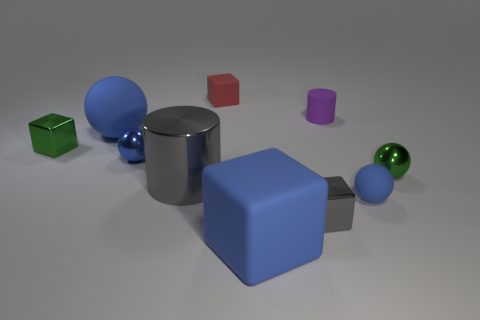Subtract all green cylinders. How many blue balls are left? 3 Subtract 1 spheres. How many spheres are left? 3 Subtract all balls. How many objects are left? 6 Add 5 big blue blocks. How many big blue blocks are left? 6 Add 1 small blue shiny balls. How many small blue shiny balls exist? 2 Subtract 1 purple cylinders. How many objects are left? 9 Subtract all red things. Subtract all green metal balls. How many objects are left? 8 